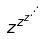Convert formula to latex. <formula><loc_0><loc_0><loc_500><loc_500>z ^ { z ^ { z ^ { \cdot ^ { \cdot ^ { \cdot } } } } }</formula> 